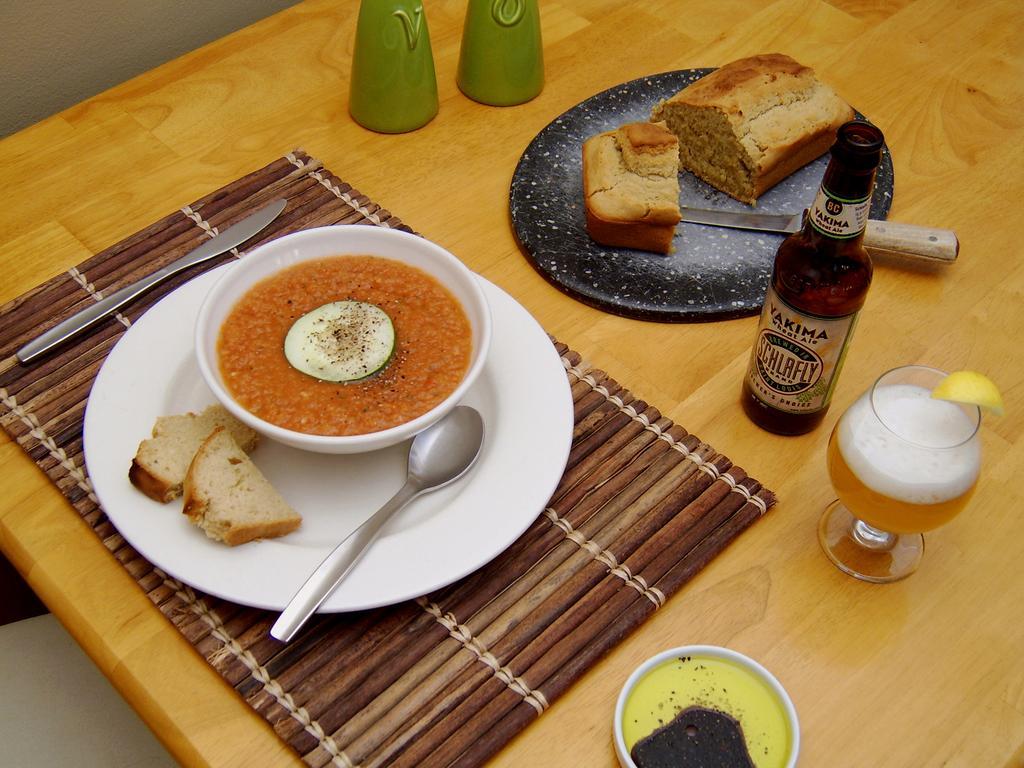Can you describe this image briefly? Here on a table we can see a glass with and a lemon slice on it and on a plate there is a bread and knife,two objects and a cup with liquid in it and on a object there is a plate with bread pieces,spoon and a bowl with liquid in it and also there is a knife here. There are some other objects also but not clear. 